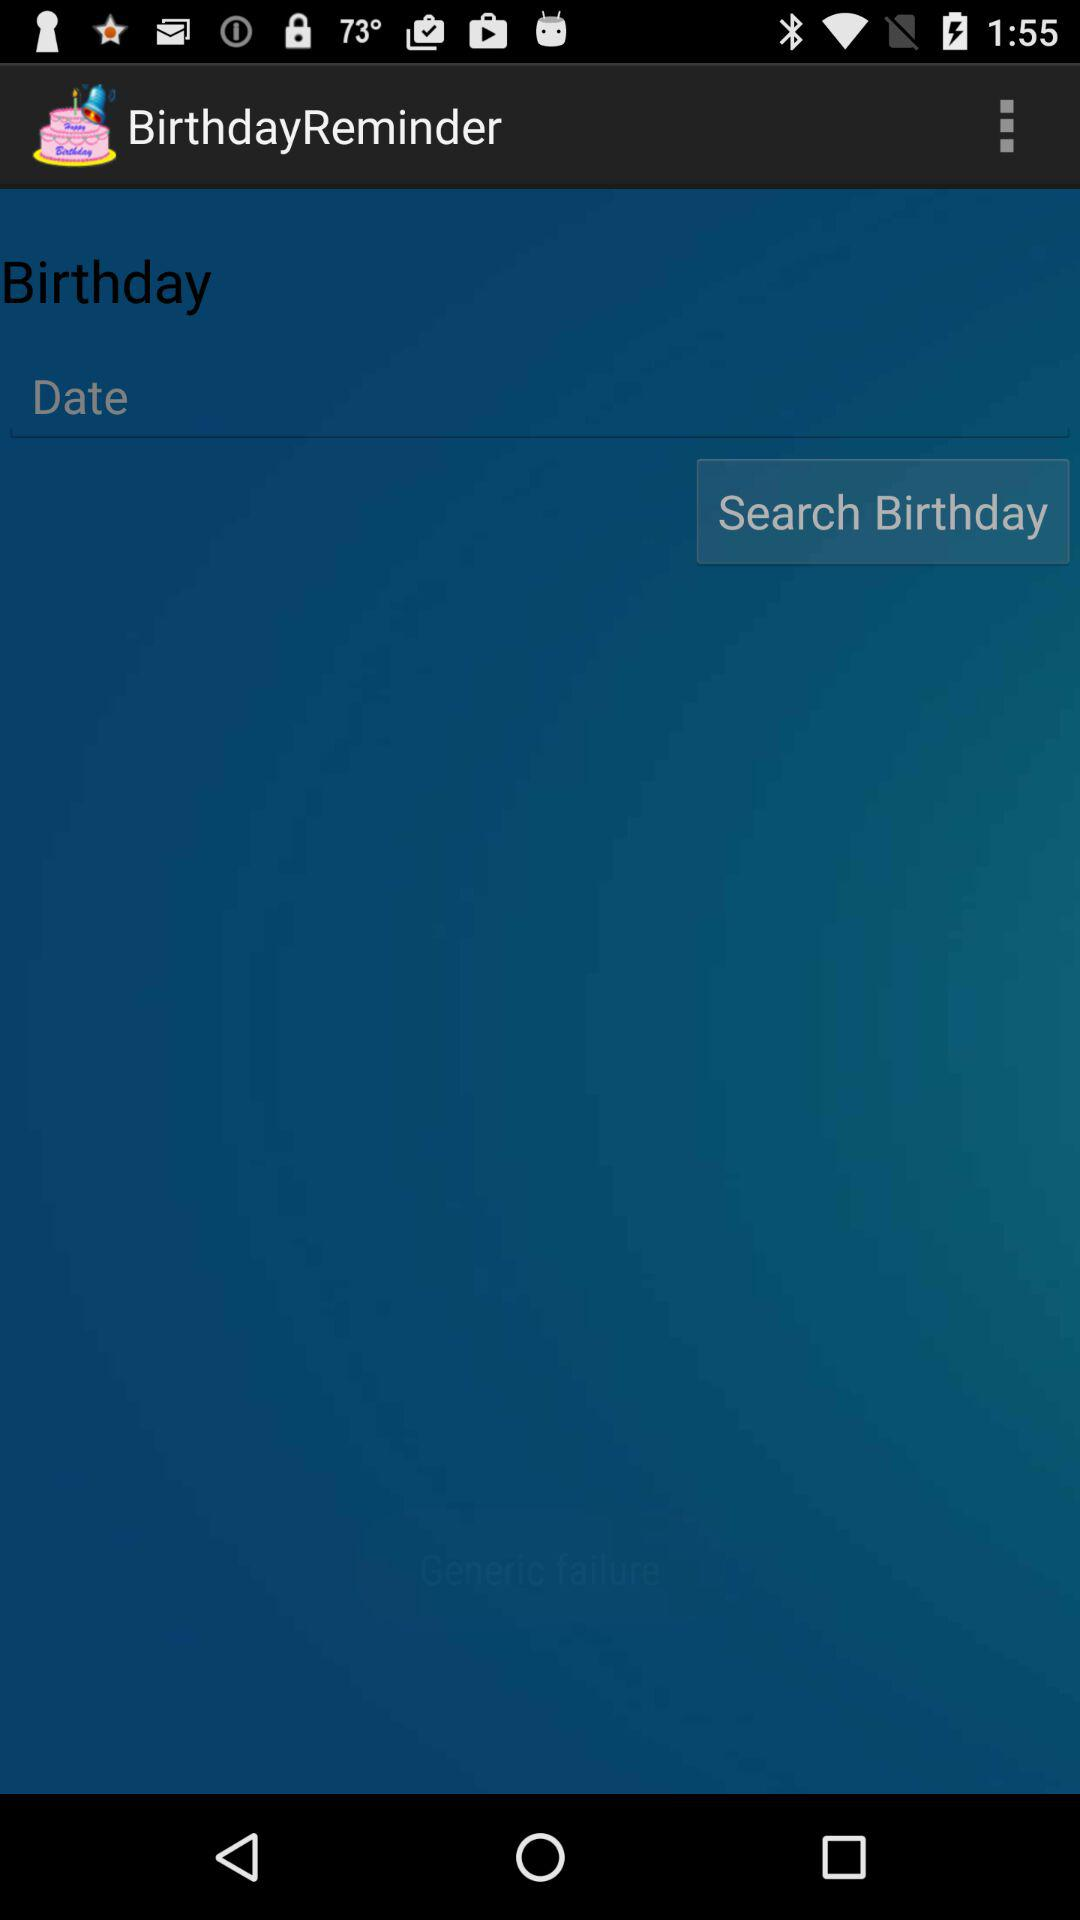What is the name of the application? The name of the application is "BirthdayReminder". 